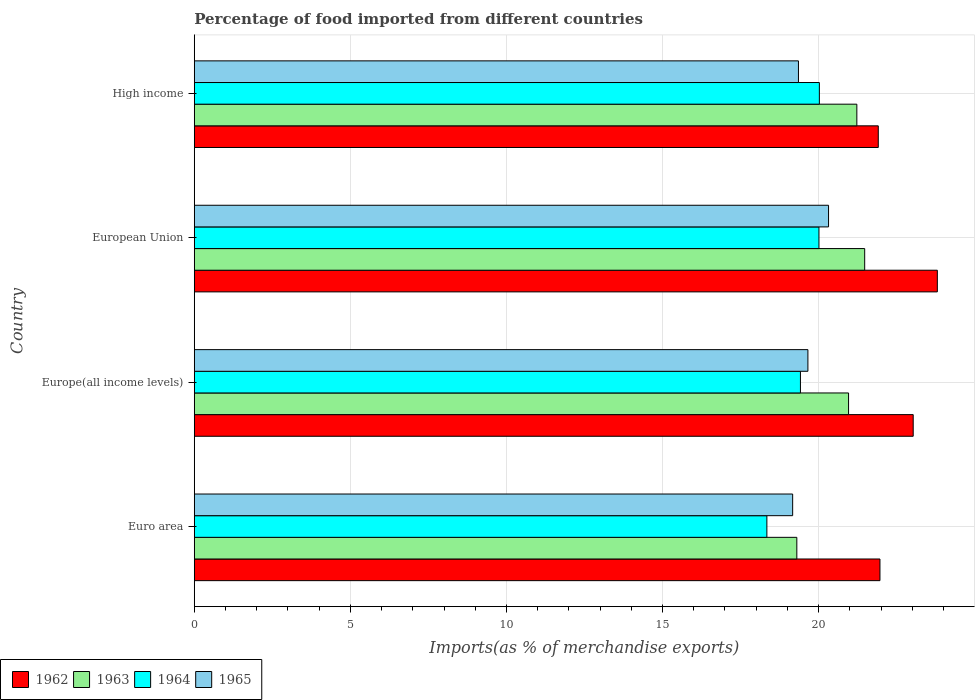Are the number of bars per tick equal to the number of legend labels?
Keep it short and to the point. Yes. How many bars are there on the 3rd tick from the top?
Offer a very short reply. 4. What is the percentage of imports to different countries in 1965 in European Union?
Your response must be concise. 20.32. Across all countries, what is the maximum percentage of imports to different countries in 1965?
Make the answer very short. 20.32. Across all countries, what is the minimum percentage of imports to different countries in 1965?
Offer a terse response. 19.17. In which country was the percentage of imports to different countries in 1964 minimum?
Your response must be concise. Euro area. What is the total percentage of imports to different countries in 1963 in the graph?
Make the answer very short. 82.97. What is the difference between the percentage of imports to different countries in 1963 in Euro area and that in Europe(all income levels)?
Give a very brief answer. -1.66. What is the difference between the percentage of imports to different countries in 1962 in High income and the percentage of imports to different countries in 1964 in Europe(all income levels)?
Make the answer very short. 2.49. What is the average percentage of imports to different countries in 1962 per country?
Your answer should be very brief. 22.68. What is the difference between the percentage of imports to different countries in 1962 and percentage of imports to different countries in 1963 in Euro area?
Ensure brevity in your answer.  2.66. In how many countries, is the percentage of imports to different countries in 1963 greater than 4 %?
Offer a very short reply. 4. What is the ratio of the percentage of imports to different countries in 1962 in Europe(all income levels) to that in High income?
Your answer should be very brief. 1.05. Is the difference between the percentage of imports to different countries in 1962 in Euro area and High income greater than the difference between the percentage of imports to different countries in 1963 in Euro area and High income?
Keep it short and to the point. Yes. What is the difference between the highest and the second highest percentage of imports to different countries in 1962?
Offer a terse response. 0.77. What is the difference between the highest and the lowest percentage of imports to different countries in 1963?
Provide a succinct answer. 2.17. Is the sum of the percentage of imports to different countries in 1965 in Europe(all income levels) and European Union greater than the maximum percentage of imports to different countries in 1962 across all countries?
Your answer should be very brief. Yes. Is it the case that in every country, the sum of the percentage of imports to different countries in 1964 and percentage of imports to different countries in 1963 is greater than the sum of percentage of imports to different countries in 1965 and percentage of imports to different countries in 1962?
Make the answer very short. No. What does the 2nd bar from the top in European Union represents?
Keep it short and to the point. 1964. What does the 3rd bar from the bottom in Europe(all income levels) represents?
Offer a very short reply. 1964. Is it the case that in every country, the sum of the percentage of imports to different countries in 1965 and percentage of imports to different countries in 1963 is greater than the percentage of imports to different countries in 1964?
Provide a succinct answer. Yes. How many countries are there in the graph?
Provide a short and direct response. 4. Where does the legend appear in the graph?
Give a very brief answer. Bottom left. How many legend labels are there?
Offer a terse response. 4. What is the title of the graph?
Keep it short and to the point. Percentage of food imported from different countries. What is the label or title of the X-axis?
Your response must be concise. Imports(as % of merchandise exports). What is the label or title of the Y-axis?
Give a very brief answer. Country. What is the Imports(as % of merchandise exports) in 1962 in Euro area?
Offer a very short reply. 21.97. What is the Imports(as % of merchandise exports) in 1963 in Euro area?
Offer a terse response. 19.3. What is the Imports(as % of merchandise exports) in 1964 in Euro area?
Offer a very short reply. 18.34. What is the Imports(as % of merchandise exports) of 1965 in Euro area?
Your answer should be very brief. 19.17. What is the Imports(as % of merchandise exports) of 1962 in Europe(all income levels)?
Provide a short and direct response. 23.03. What is the Imports(as % of merchandise exports) in 1963 in Europe(all income levels)?
Offer a very short reply. 20.96. What is the Imports(as % of merchandise exports) in 1964 in Europe(all income levels)?
Provide a short and direct response. 19.42. What is the Imports(as % of merchandise exports) of 1965 in Europe(all income levels)?
Your answer should be very brief. 19.66. What is the Imports(as % of merchandise exports) of 1962 in European Union?
Offer a very short reply. 23.8. What is the Imports(as % of merchandise exports) in 1963 in European Union?
Give a very brief answer. 21.48. What is the Imports(as % of merchandise exports) of 1964 in European Union?
Your response must be concise. 20.01. What is the Imports(as % of merchandise exports) of 1965 in European Union?
Give a very brief answer. 20.32. What is the Imports(as % of merchandise exports) in 1962 in High income?
Your response must be concise. 21.91. What is the Imports(as % of merchandise exports) in 1963 in High income?
Your answer should be compact. 21.23. What is the Imports(as % of merchandise exports) in 1964 in High income?
Your answer should be compact. 20.02. What is the Imports(as % of merchandise exports) in 1965 in High income?
Give a very brief answer. 19.36. Across all countries, what is the maximum Imports(as % of merchandise exports) in 1962?
Keep it short and to the point. 23.8. Across all countries, what is the maximum Imports(as % of merchandise exports) in 1963?
Offer a very short reply. 21.48. Across all countries, what is the maximum Imports(as % of merchandise exports) in 1964?
Your answer should be compact. 20.02. Across all countries, what is the maximum Imports(as % of merchandise exports) in 1965?
Your response must be concise. 20.32. Across all countries, what is the minimum Imports(as % of merchandise exports) of 1962?
Make the answer very short. 21.91. Across all countries, what is the minimum Imports(as % of merchandise exports) of 1963?
Make the answer very short. 19.3. Across all countries, what is the minimum Imports(as % of merchandise exports) of 1964?
Provide a short and direct response. 18.34. Across all countries, what is the minimum Imports(as % of merchandise exports) in 1965?
Keep it short and to the point. 19.17. What is the total Imports(as % of merchandise exports) of 1962 in the graph?
Your answer should be compact. 90.71. What is the total Imports(as % of merchandise exports) in 1963 in the graph?
Your answer should be compact. 82.97. What is the total Imports(as % of merchandise exports) of 1964 in the graph?
Make the answer very short. 77.8. What is the total Imports(as % of merchandise exports) in 1965 in the graph?
Give a very brief answer. 78.5. What is the difference between the Imports(as % of merchandise exports) in 1962 in Euro area and that in Europe(all income levels)?
Provide a succinct answer. -1.07. What is the difference between the Imports(as % of merchandise exports) of 1963 in Euro area and that in Europe(all income levels)?
Keep it short and to the point. -1.66. What is the difference between the Imports(as % of merchandise exports) in 1964 in Euro area and that in Europe(all income levels)?
Ensure brevity in your answer.  -1.08. What is the difference between the Imports(as % of merchandise exports) in 1965 in Euro area and that in Europe(all income levels)?
Offer a very short reply. -0.49. What is the difference between the Imports(as % of merchandise exports) in 1962 in Euro area and that in European Union?
Offer a very short reply. -1.84. What is the difference between the Imports(as % of merchandise exports) in 1963 in Euro area and that in European Union?
Ensure brevity in your answer.  -2.17. What is the difference between the Imports(as % of merchandise exports) in 1964 in Euro area and that in European Union?
Your answer should be compact. -1.67. What is the difference between the Imports(as % of merchandise exports) of 1965 in Euro area and that in European Union?
Keep it short and to the point. -1.15. What is the difference between the Imports(as % of merchandise exports) in 1962 in Euro area and that in High income?
Your answer should be compact. 0.05. What is the difference between the Imports(as % of merchandise exports) of 1963 in Euro area and that in High income?
Make the answer very short. -1.92. What is the difference between the Imports(as % of merchandise exports) in 1964 in Euro area and that in High income?
Ensure brevity in your answer.  -1.68. What is the difference between the Imports(as % of merchandise exports) of 1965 in Euro area and that in High income?
Make the answer very short. -0.19. What is the difference between the Imports(as % of merchandise exports) in 1962 in Europe(all income levels) and that in European Union?
Keep it short and to the point. -0.77. What is the difference between the Imports(as % of merchandise exports) in 1963 in Europe(all income levels) and that in European Union?
Provide a succinct answer. -0.52. What is the difference between the Imports(as % of merchandise exports) in 1964 in Europe(all income levels) and that in European Union?
Your response must be concise. -0.59. What is the difference between the Imports(as % of merchandise exports) of 1965 in Europe(all income levels) and that in European Union?
Your answer should be very brief. -0.66. What is the difference between the Imports(as % of merchandise exports) of 1962 in Europe(all income levels) and that in High income?
Provide a succinct answer. 1.12. What is the difference between the Imports(as % of merchandise exports) in 1963 in Europe(all income levels) and that in High income?
Give a very brief answer. -0.27. What is the difference between the Imports(as % of merchandise exports) of 1964 in Europe(all income levels) and that in High income?
Offer a terse response. -0.61. What is the difference between the Imports(as % of merchandise exports) of 1965 in Europe(all income levels) and that in High income?
Ensure brevity in your answer.  0.3. What is the difference between the Imports(as % of merchandise exports) in 1962 in European Union and that in High income?
Ensure brevity in your answer.  1.89. What is the difference between the Imports(as % of merchandise exports) in 1963 in European Union and that in High income?
Make the answer very short. 0.25. What is the difference between the Imports(as % of merchandise exports) in 1964 in European Union and that in High income?
Offer a very short reply. -0.01. What is the difference between the Imports(as % of merchandise exports) of 1965 in European Union and that in High income?
Offer a terse response. 0.96. What is the difference between the Imports(as % of merchandise exports) in 1962 in Euro area and the Imports(as % of merchandise exports) in 1963 in Europe(all income levels)?
Provide a short and direct response. 1.01. What is the difference between the Imports(as % of merchandise exports) of 1962 in Euro area and the Imports(as % of merchandise exports) of 1964 in Europe(all income levels)?
Offer a very short reply. 2.55. What is the difference between the Imports(as % of merchandise exports) in 1962 in Euro area and the Imports(as % of merchandise exports) in 1965 in Europe(all income levels)?
Keep it short and to the point. 2.31. What is the difference between the Imports(as % of merchandise exports) of 1963 in Euro area and the Imports(as % of merchandise exports) of 1964 in Europe(all income levels)?
Offer a very short reply. -0.12. What is the difference between the Imports(as % of merchandise exports) of 1963 in Euro area and the Imports(as % of merchandise exports) of 1965 in Europe(all income levels)?
Offer a terse response. -0.35. What is the difference between the Imports(as % of merchandise exports) in 1964 in Euro area and the Imports(as % of merchandise exports) in 1965 in Europe(all income levels)?
Ensure brevity in your answer.  -1.31. What is the difference between the Imports(as % of merchandise exports) of 1962 in Euro area and the Imports(as % of merchandise exports) of 1963 in European Union?
Your response must be concise. 0.49. What is the difference between the Imports(as % of merchandise exports) in 1962 in Euro area and the Imports(as % of merchandise exports) in 1964 in European Union?
Provide a short and direct response. 1.95. What is the difference between the Imports(as % of merchandise exports) in 1962 in Euro area and the Imports(as % of merchandise exports) in 1965 in European Union?
Your response must be concise. 1.65. What is the difference between the Imports(as % of merchandise exports) in 1963 in Euro area and the Imports(as % of merchandise exports) in 1964 in European Union?
Keep it short and to the point. -0.71. What is the difference between the Imports(as % of merchandise exports) of 1963 in Euro area and the Imports(as % of merchandise exports) of 1965 in European Union?
Give a very brief answer. -1.02. What is the difference between the Imports(as % of merchandise exports) in 1964 in Euro area and the Imports(as % of merchandise exports) in 1965 in European Union?
Your answer should be very brief. -1.98. What is the difference between the Imports(as % of merchandise exports) in 1962 in Euro area and the Imports(as % of merchandise exports) in 1963 in High income?
Your answer should be compact. 0.74. What is the difference between the Imports(as % of merchandise exports) of 1962 in Euro area and the Imports(as % of merchandise exports) of 1964 in High income?
Give a very brief answer. 1.94. What is the difference between the Imports(as % of merchandise exports) of 1962 in Euro area and the Imports(as % of merchandise exports) of 1965 in High income?
Give a very brief answer. 2.61. What is the difference between the Imports(as % of merchandise exports) of 1963 in Euro area and the Imports(as % of merchandise exports) of 1964 in High income?
Make the answer very short. -0.72. What is the difference between the Imports(as % of merchandise exports) of 1963 in Euro area and the Imports(as % of merchandise exports) of 1965 in High income?
Your response must be concise. -0.05. What is the difference between the Imports(as % of merchandise exports) of 1964 in Euro area and the Imports(as % of merchandise exports) of 1965 in High income?
Offer a very short reply. -1.01. What is the difference between the Imports(as % of merchandise exports) of 1962 in Europe(all income levels) and the Imports(as % of merchandise exports) of 1963 in European Union?
Provide a succinct answer. 1.55. What is the difference between the Imports(as % of merchandise exports) in 1962 in Europe(all income levels) and the Imports(as % of merchandise exports) in 1964 in European Union?
Provide a succinct answer. 3.02. What is the difference between the Imports(as % of merchandise exports) in 1962 in Europe(all income levels) and the Imports(as % of merchandise exports) in 1965 in European Union?
Your answer should be compact. 2.71. What is the difference between the Imports(as % of merchandise exports) in 1963 in Europe(all income levels) and the Imports(as % of merchandise exports) in 1964 in European Union?
Offer a very short reply. 0.95. What is the difference between the Imports(as % of merchandise exports) of 1963 in Europe(all income levels) and the Imports(as % of merchandise exports) of 1965 in European Union?
Offer a terse response. 0.64. What is the difference between the Imports(as % of merchandise exports) of 1964 in Europe(all income levels) and the Imports(as % of merchandise exports) of 1965 in European Union?
Offer a very short reply. -0.9. What is the difference between the Imports(as % of merchandise exports) in 1962 in Europe(all income levels) and the Imports(as % of merchandise exports) in 1963 in High income?
Ensure brevity in your answer.  1.81. What is the difference between the Imports(as % of merchandise exports) in 1962 in Europe(all income levels) and the Imports(as % of merchandise exports) in 1964 in High income?
Provide a short and direct response. 3.01. What is the difference between the Imports(as % of merchandise exports) in 1962 in Europe(all income levels) and the Imports(as % of merchandise exports) in 1965 in High income?
Make the answer very short. 3.68. What is the difference between the Imports(as % of merchandise exports) in 1963 in Europe(all income levels) and the Imports(as % of merchandise exports) in 1964 in High income?
Your response must be concise. 0.94. What is the difference between the Imports(as % of merchandise exports) in 1963 in Europe(all income levels) and the Imports(as % of merchandise exports) in 1965 in High income?
Provide a succinct answer. 1.61. What is the difference between the Imports(as % of merchandise exports) of 1964 in Europe(all income levels) and the Imports(as % of merchandise exports) of 1965 in High income?
Give a very brief answer. 0.06. What is the difference between the Imports(as % of merchandise exports) in 1962 in European Union and the Imports(as % of merchandise exports) in 1963 in High income?
Keep it short and to the point. 2.58. What is the difference between the Imports(as % of merchandise exports) in 1962 in European Union and the Imports(as % of merchandise exports) in 1964 in High income?
Provide a succinct answer. 3.78. What is the difference between the Imports(as % of merchandise exports) of 1962 in European Union and the Imports(as % of merchandise exports) of 1965 in High income?
Provide a succinct answer. 4.45. What is the difference between the Imports(as % of merchandise exports) of 1963 in European Union and the Imports(as % of merchandise exports) of 1964 in High income?
Ensure brevity in your answer.  1.45. What is the difference between the Imports(as % of merchandise exports) in 1963 in European Union and the Imports(as % of merchandise exports) in 1965 in High income?
Offer a terse response. 2.12. What is the difference between the Imports(as % of merchandise exports) in 1964 in European Union and the Imports(as % of merchandise exports) in 1965 in High income?
Your response must be concise. 0.66. What is the average Imports(as % of merchandise exports) of 1962 per country?
Offer a very short reply. 22.68. What is the average Imports(as % of merchandise exports) of 1963 per country?
Provide a short and direct response. 20.74. What is the average Imports(as % of merchandise exports) of 1964 per country?
Make the answer very short. 19.45. What is the average Imports(as % of merchandise exports) of 1965 per country?
Give a very brief answer. 19.63. What is the difference between the Imports(as % of merchandise exports) of 1962 and Imports(as % of merchandise exports) of 1963 in Euro area?
Provide a succinct answer. 2.66. What is the difference between the Imports(as % of merchandise exports) in 1962 and Imports(as % of merchandise exports) in 1964 in Euro area?
Your answer should be compact. 3.62. What is the difference between the Imports(as % of merchandise exports) of 1962 and Imports(as % of merchandise exports) of 1965 in Euro area?
Ensure brevity in your answer.  2.8. What is the difference between the Imports(as % of merchandise exports) in 1963 and Imports(as % of merchandise exports) in 1964 in Euro area?
Your response must be concise. 0.96. What is the difference between the Imports(as % of merchandise exports) in 1963 and Imports(as % of merchandise exports) in 1965 in Euro area?
Your response must be concise. 0.13. What is the difference between the Imports(as % of merchandise exports) in 1964 and Imports(as % of merchandise exports) in 1965 in Euro area?
Provide a short and direct response. -0.83. What is the difference between the Imports(as % of merchandise exports) in 1962 and Imports(as % of merchandise exports) in 1963 in Europe(all income levels)?
Your answer should be compact. 2.07. What is the difference between the Imports(as % of merchandise exports) in 1962 and Imports(as % of merchandise exports) in 1964 in Europe(all income levels)?
Provide a short and direct response. 3.61. What is the difference between the Imports(as % of merchandise exports) of 1962 and Imports(as % of merchandise exports) of 1965 in Europe(all income levels)?
Your answer should be compact. 3.37. What is the difference between the Imports(as % of merchandise exports) of 1963 and Imports(as % of merchandise exports) of 1964 in Europe(all income levels)?
Your answer should be compact. 1.54. What is the difference between the Imports(as % of merchandise exports) in 1963 and Imports(as % of merchandise exports) in 1965 in Europe(all income levels)?
Make the answer very short. 1.3. What is the difference between the Imports(as % of merchandise exports) of 1964 and Imports(as % of merchandise exports) of 1965 in Europe(all income levels)?
Keep it short and to the point. -0.24. What is the difference between the Imports(as % of merchandise exports) of 1962 and Imports(as % of merchandise exports) of 1963 in European Union?
Offer a terse response. 2.33. What is the difference between the Imports(as % of merchandise exports) of 1962 and Imports(as % of merchandise exports) of 1964 in European Union?
Your response must be concise. 3.79. What is the difference between the Imports(as % of merchandise exports) of 1962 and Imports(as % of merchandise exports) of 1965 in European Union?
Your answer should be compact. 3.49. What is the difference between the Imports(as % of merchandise exports) of 1963 and Imports(as % of merchandise exports) of 1964 in European Union?
Make the answer very short. 1.46. What is the difference between the Imports(as % of merchandise exports) of 1963 and Imports(as % of merchandise exports) of 1965 in European Union?
Your answer should be compact. 1.16. What is the difference between the Imports(as % of merchandise exports) in 1964 and Imports(as % of merchandise exports) in 1965 in European Union?
Provide a succinct answer. -0.31. What is the difference between the Imports(as % of merchandise exports) of 1962 and Imports(as % of merchandise exports) of 1963 in High income?
Offer a terse response. 0.69. What is the difference between the Imports(as % of merchandise exports) in 1962 and Imports(as % of merchandise exports) in 1964 in High income?
Provide a short and direct response. 1.89. What is the difference between the Imports(as % of merchandise exports) in 1962 and Imports(as % of merchandise exports) in 1965 in High income?
Give a very brief answer. 2.56. What is the difference between the Imports(as % of merchandise exports) in 1963 and Imports(as % of merchandise exports) in 1964 in High income?
Keep it short and to the point. 1.2. What is the difference between the Imports(as % of merchandise exports) of 1963 and Imports(as % of merchandise exports) of 1965 in High income?
Provide a succinct answer. 1.87. What is the difference between the Imports(as % of merchandise exports) of 1964 and Imports(as % of merchandise exports) of 1965 in High income?
Your response must be concise. 0.67. What is the ratio of the Imports(as % of merchandise exports) in 1962 in Euro area to that in Europe(all income levels)?
Your answer should be very brief. 0.95. What is the ratio of the Imports(as % of merchandise exports) of 1963 in Euro area to that in Europe(all income levels)?
Make the answer very short. 0.92. What is the ratio of the Imports(as % of merchandise exports) of 1964 in Euro area to that in Europe(all income levels)?
Ensure brevity in your answer.  0.94. What is the ratio of the Imports(as % of merchandise exports) of 1965 in Euro area to that in Europe(all income levels)?
Provide a succinct answer. 0.98. What is the ratio of the Imports(as % of merchandise exports) in 1962 in Euro area to that in European Union?
Ensure brevity in your answer.  0.92. What is the ratio of the Imports(as % of merchandise exports) of 1963 in Euro area to that in European Union?
Your answer should be compact. 0.9. What is the ratio of the Imports(as % of merchandise exports) of 1964 in Euro area to that in European Union?
Make the answer very short. 0.92. What is the ratio of the Imports(as % of merchandise exports) in 1965 in Euro area to that in European Union?
Keep it short and to the point. 0.94. What is the ratio of the Imports(as % of merchandise exports) of 1963 in Euro area to that in High income?
Make the answer very short. 0.91. What is the ratio of the Imports(as % of merchandise exports) of 1964 in Euro area to that in High income?
Your response must be concise. 0.92. What is the ratio of the Imports(as % of merchandise exports) in 1965 in Euro area to that in High income?
Your answer should be very brief. 0.99. What is the ratio of the Imports(as % of merchandise exports) in 1962 in Europe(all income levels) to that in European Union?
Give a very brief answer. 0.97. What is the ratio of the Imports(as % of merchandise exports) in 1963 in Europe(all income levels) to that in European Union?
Provide a succinct answer. 0.98. What is the ratio of the Imports(as % of merchandise exports) of 1964 in Europe(all income levels) to that in European Union?
Provide a succinct answer. 0.97. What is the ratio of the Imports(as % of merchandise exports) in 1965 in Europe(all income levels) to that in European Union?
Give a very brief answer. 0.97. What is the ratio of the Imports(as % of merchandise exports) in 1962 in Europe(all income levels) to that in High income?
Make the answer very short. 1.05. What is the ratio of the Imports(as % of merchandise exports) in 1963 in Europe(all income levels) to that in High income?
Your answer should be compact. 0.99. What is the ratio of the Imports(as % of merchandise exports) in 1964 in Europe(all income levels) to that in High income?
Your answer should be compact. 0.97. What is the ratio of the Imports(as % of merchandise exports) in 1965 in Europe(all income levels) to that in High income?
Your response must be concise. 1.02. What is the ratio of the Imports(as % of merchandise exports) of 1962 in European Union to that in High income?
Your response must be concise. 1.09. What is the ratio of the Imports(as % of merchandise exports) of 1963 in European Union to that in High income?
Ensure brevity in your answer.  1.01. What is the ratio of the Imports(as % of merchandise exports) in 1964 in European Union to that in High income?
Provide a short and direct response. 1. What is the ratio of the Imports(as % of merchandise exports) of 1965 in European Union to that in High income?
Provide a succinct answer. 1.05. What is the difference between the highest and the second highest Imports(as % of merchandise exports) of 1962?
Keep it short and to the point. 0.77. What is the difference between the highest and the second highest Imports(as % of merchandise exports) in 1963?
Ensure brevity in your answer.  0.25. What is the difference between the highest and the second highest Imports(as % of merchandise exports) of 1964?
Your answer should be compact. 0.01. What is the difference between the highest and the second highest Imports(as % of merchandise exports) in 1965?
Make the answer very short. 0.66. What is the difference between the highest and the lowest Imports(as % of merchandise exports) in 1962?
Keep it short and to the point. 1.89. What is the difference between the highest and the lowest Imports(as % of merchandise exports) in 1963?
Offer a very short reply. 2.17. What is the difference between the highest and the lowest Imports(as % of merchandise exports) in 1964?
Provide a succinct answer. 1.68. What is the difference between the highest and the lowest Imports(as % of merchandise exports) in 1965?
Keep it short and to the point. 1.15. 